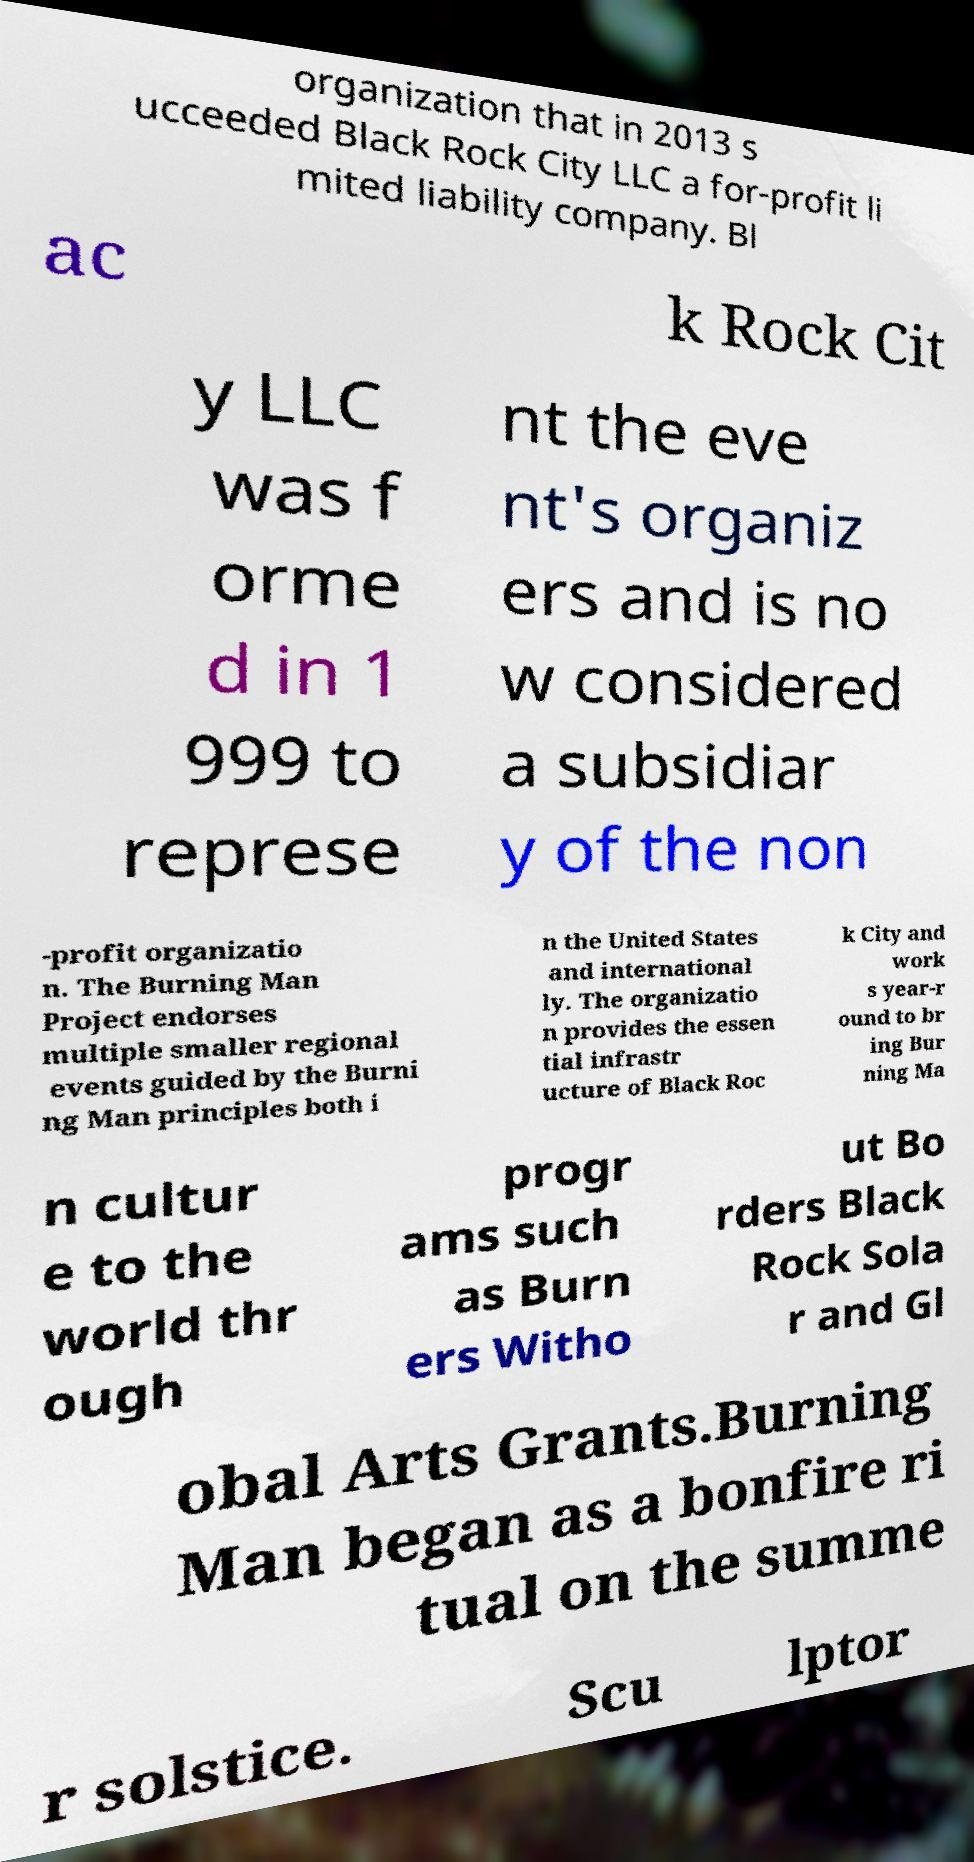What messages or text are displayed in this image? I need them in a readable, typed format. organization that in 2013 s ucceeded Black Rock City LLC a for-profit li mited liability company. Bl ac k Rock Cit y LLC was f orme d in 1 999 to represe nt the eve nt's organiz ers and is no w considered a subsidiar y of the non -profit organizatio n. The Burning Man Project endorses multiple smaller regional events guided by the Burni ng Man principles both i n the United States and international ly. The organizatio n provides the essen tial infrastr ucture of Black Roc k City and work s year-r ound to br ing Bur ning Ma n cultur e to the world thr ough progr ams such as Burn ers Witho ut Bo rders Black Rock Sola r and Gl obal Arts Grants.Burning Man began as a bonfire ri tual on the summe r solstice. Scu lptor 